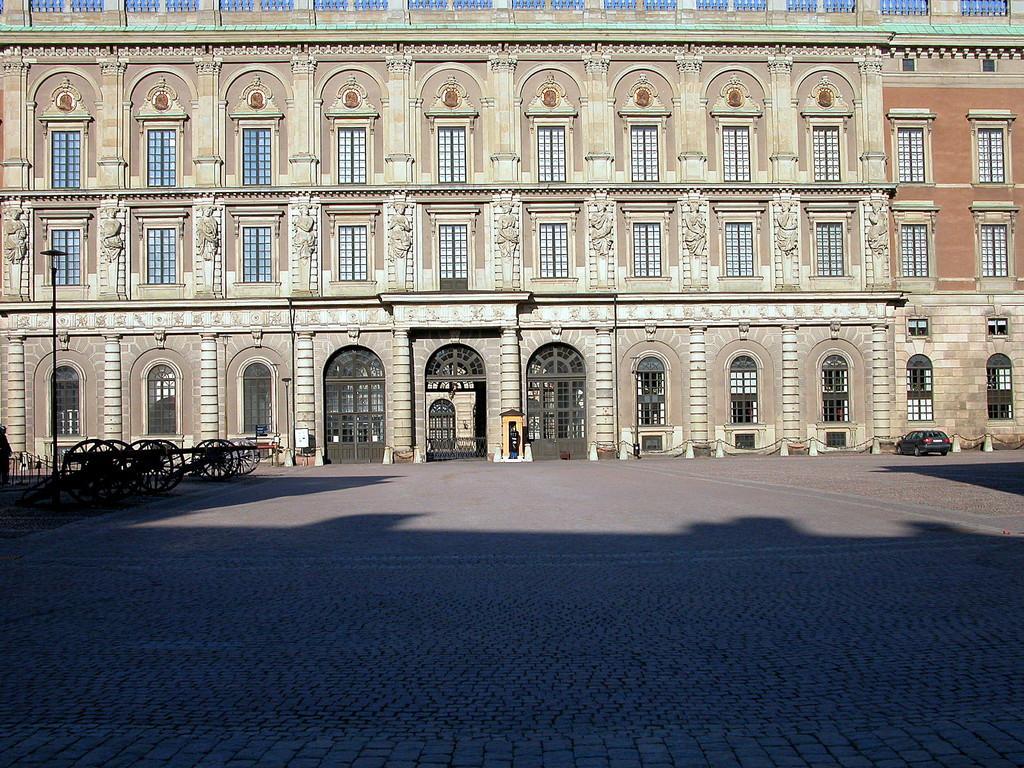Could you give a brief overview of what you see in this image? In this picture we can see the ground, car, carts, building with windows and some objects. 